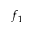<formula> <loc_0><loc_0><loc_500><loc_500>f _ { 1 }</formula> 